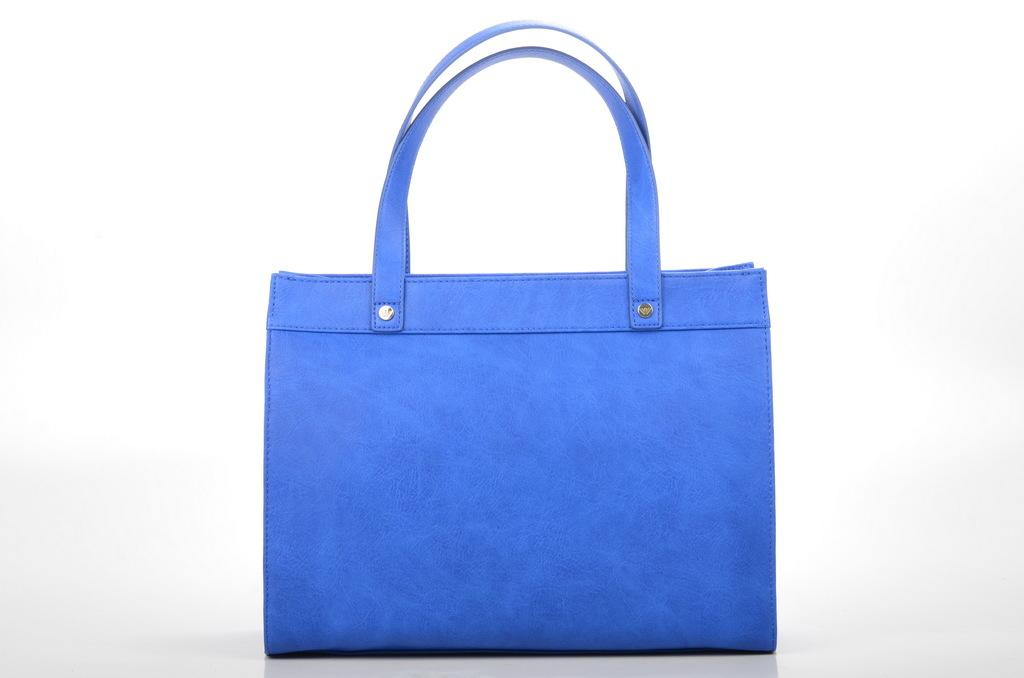What type of accessory is present in the image? There is a handbag in the image. What color is the handbag? The handbag is blue in color. Is there a waterfall visible in the image? No, there is no waterfall or any water-related element present in the image. 